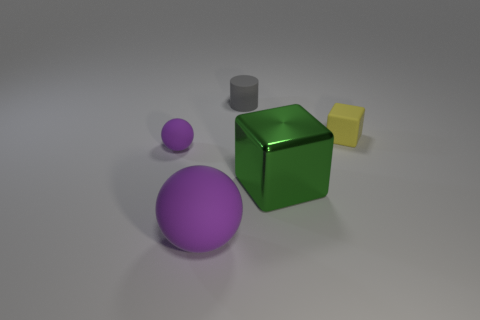Add 5 metallic blocks. How many objects exist? 10 Add 3 small purple metal balls. How many small purple metal balls exist? 3 Subtract 1 purple balls. How many objects are left? 4 Subtract all cylinders. How many objects are left? 4 Subtract 1 blocks. How many blocks are left? 1 Subtract all cyan spheres. Subtract all blue cubes. How many spheres are left? 2 Subtract all green balls. How many green blocks are left? 1 Subtract all big yellow metal things. Subtract all small balls. How many objects are left? 4 Add 2 cubes. How many cubes are left? 4 